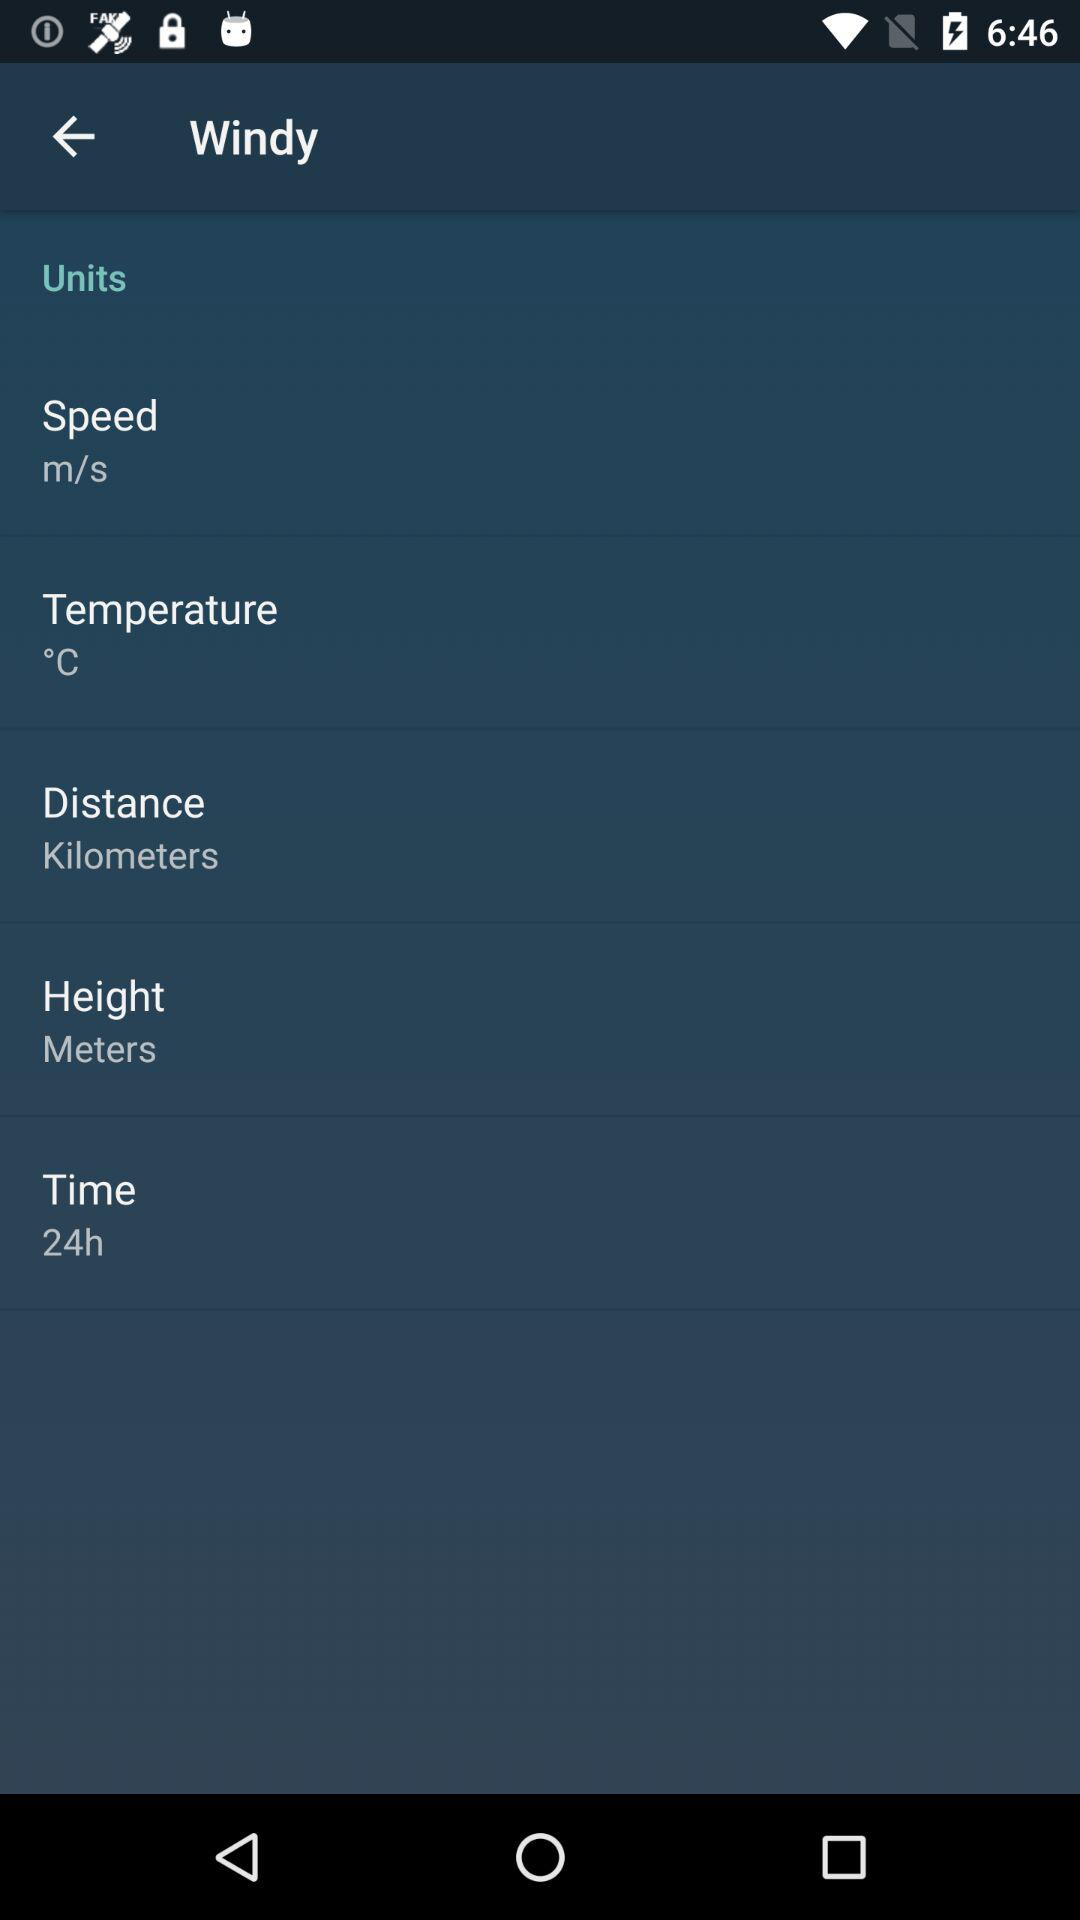How many units are displayed in Celsius?
Answer the question using a single word or phrase. 1 